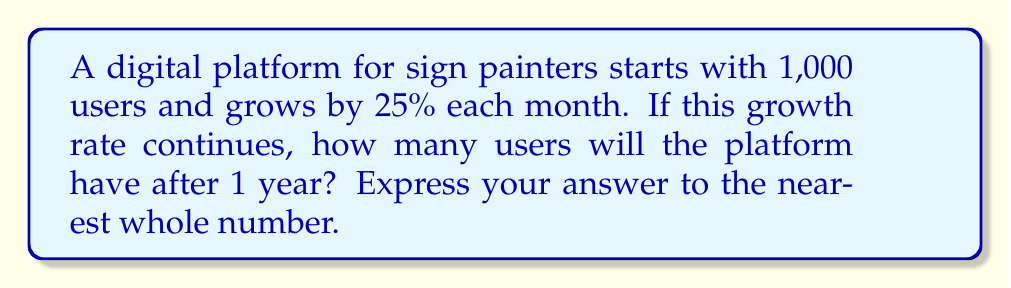Show me your answer to this math problem. Let's approach this step-by-step:

1) We start with 1,000 users, and the growth rate is 25% (0.25) per month.

2) We need to calculate the number of users after 12 months (1 year).

3) The exponential growth formula is:

   $A = P(1 + r)^t$

   Where:
   $A$ = Final amount
   $P$ = Initial principal balance
   $r$ = Growth rate (as a decimal)
   $t$ = Number of time periods

4) Plugging in our values:
   $P = 1000$
   $r = 0.25$
   $t = 12$

5) Now we can calculate:

   $A = 1000(1 + 0.25)^{12}$

6) Simplify inside the parentheses:

   $A = 1000(1.25)^{12}$

7) Calculate the exponent:

   $A = 1000 * 14.551915228366852$

8) Multiply:

   $A = 14551.915228366852$

9) Rounding to the nearest whole number:

   $A \approx 14552$
Answer: 14,552 users 